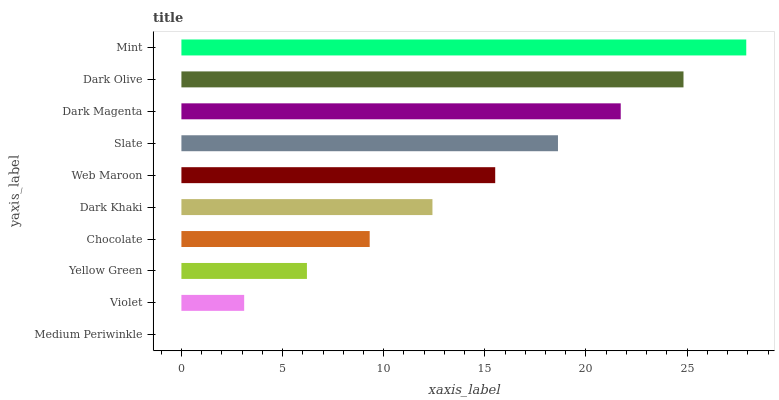Is Medium Periwinkle the minimum?
Answer yes or no. Yes. Is Mint the maximum?
Answer yes or no. Yes. Is Violet the minimum?
Answer yes or no. No. Is Violet the maximum?
Answer yes or no. No. Is Violet greater than Medium Periwinkle?
Answer yes or no. Yes. Is Medium Periwinkle less than Violet?
Answer yes or no. Yes. Is Medium Periwinkle greater than Violet?
Answer yes or no. No. Is Violet less than Medium Periwinkle?
Answer yes or no. No. Is Web Maroon the high median?
Answer yes or no. Yes. Is Dark Khaki the low median?
Answer yes or no. Yes. Is Chocolate the high median?
Answer yes or no. No. Is Dark Olive the low median?
Answer yes or no. No. 